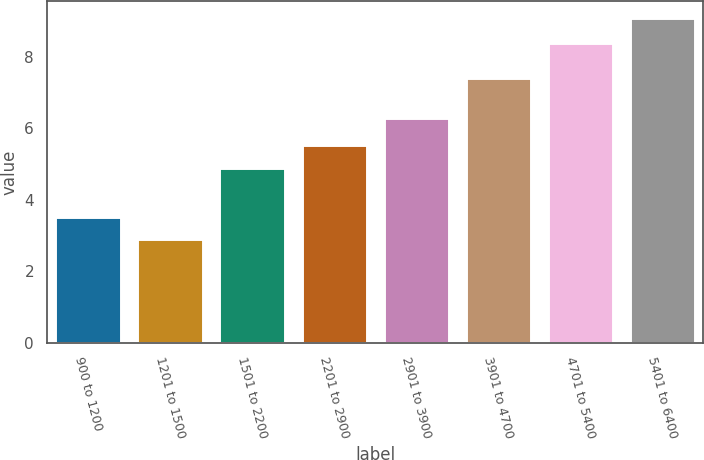Convert chart to OTSL. <chart><loc_0><loc_0><loc_500><loc_500><bar_chart><fcel>900 to 1200<fcel>1201 to 1500<fcel>1501 to 2200<fcel>2201 to 2900<fcel>2901 to 3900<fcel>3901 to 4700<fcel>4701 to 5400<fcel>5401 to 6400<nl><fcel>3.52<fcel>2.9<fcel>4.9<fcel>5.52<fcel>6.3<fcel>7.4<fcel>8.4<fcel>9.1<nl></chart> 